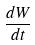<formula> <loc_0><loc_0><loc_500><loc_500>\frac { d W } { d t }</formula> 